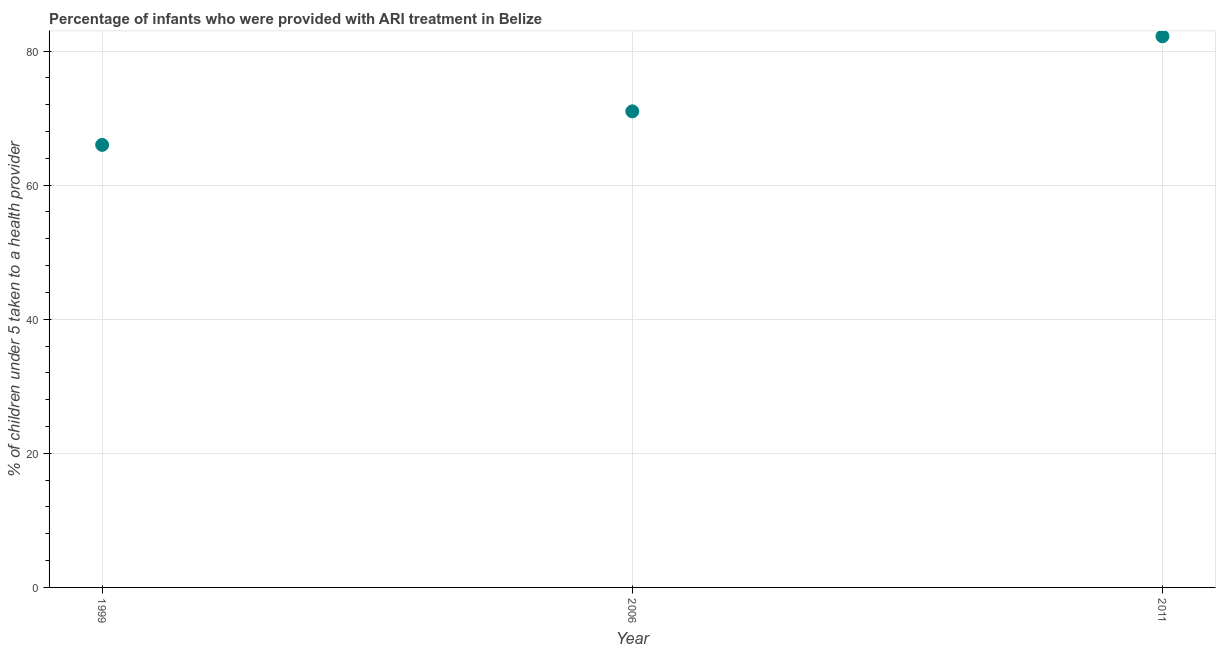What is the percentage of children who were provided with ari treatment in 2011?
Provide a succinct answer. 82.2. Across all years, what is the maximum percentage of children who were provided with ari treatment?
Offer a terse response. 82.2. Across all years, what is the minimum percentage of children who were provided with ari treatment?
Give a very brief answer. 66. What is the sum of the percentage of children who were provided with ari treatment?
Keep it short and to the point. 219.2. What is the difference between the percentage of children who were provided with ari treatment in 2006 and 2011?
Your response must be concise. -11.2. What is the average percentage of children who were provided with ari treatment per year?
Keep it short and to the point. 73.07. What is the median percentage of children who were provided with ari treatment?
Offer a very short reply. 71. What is the ratio of the percentage of children who were provided with ari treatment in 2006 to that in 2011?
Offer a very short reply. 0.86. Is the percentage of children who were provided with ari treatment in 2006 less than that in 2011?
Provide a succinct answer. Yes. Is the difference between the percentage of children who were provided with ari treatment in 2006 and 2011 greater than the difference between any two years?
Your answer should be very brief. No. What is the difference between the highest and the second highest percentage of children who were provided with ari treatment?
Ensure brevity in your answer.  11.2. What is the difference between the highest and the lowest percentage of children who were provided with ari treatment?
Offer a terse response. 16.2. Are the values on the major ticks of Y-axis written in scientific E-notation?
Your answer should be compact. No. What is the title of the graph?
Provide a succinct answer. Percentage of infants who were provided with ARI treatment in Belize. What is the label or title of the Y-axis?
Give a very brief answer. % of children under 5 taken to a health provider. What is the % of children under 5 taken to a health provider in 1999?
Provide a short and direct response. 66. What is the % of children under 5 taken to a health provider in 2011?
Offer a very short reply. 82.2. What is the difference between the % of children under 5 taken to a health provider in 1999 and 2006?
Give a very brief answer. -5. What is the difference between the % of children under 5 taken to a health provider in 1999 and 2011?
Your response must be concise. -16.2. What is the ratio of the % of children under 5 taken to a health provider in 1999 to that in 2011?
Offer a terse response. 0.8. What is the ratio of the % of children under 5 taken to a health provider in 2006 to that in 2011?
Give a very brief answer. 0.86. 